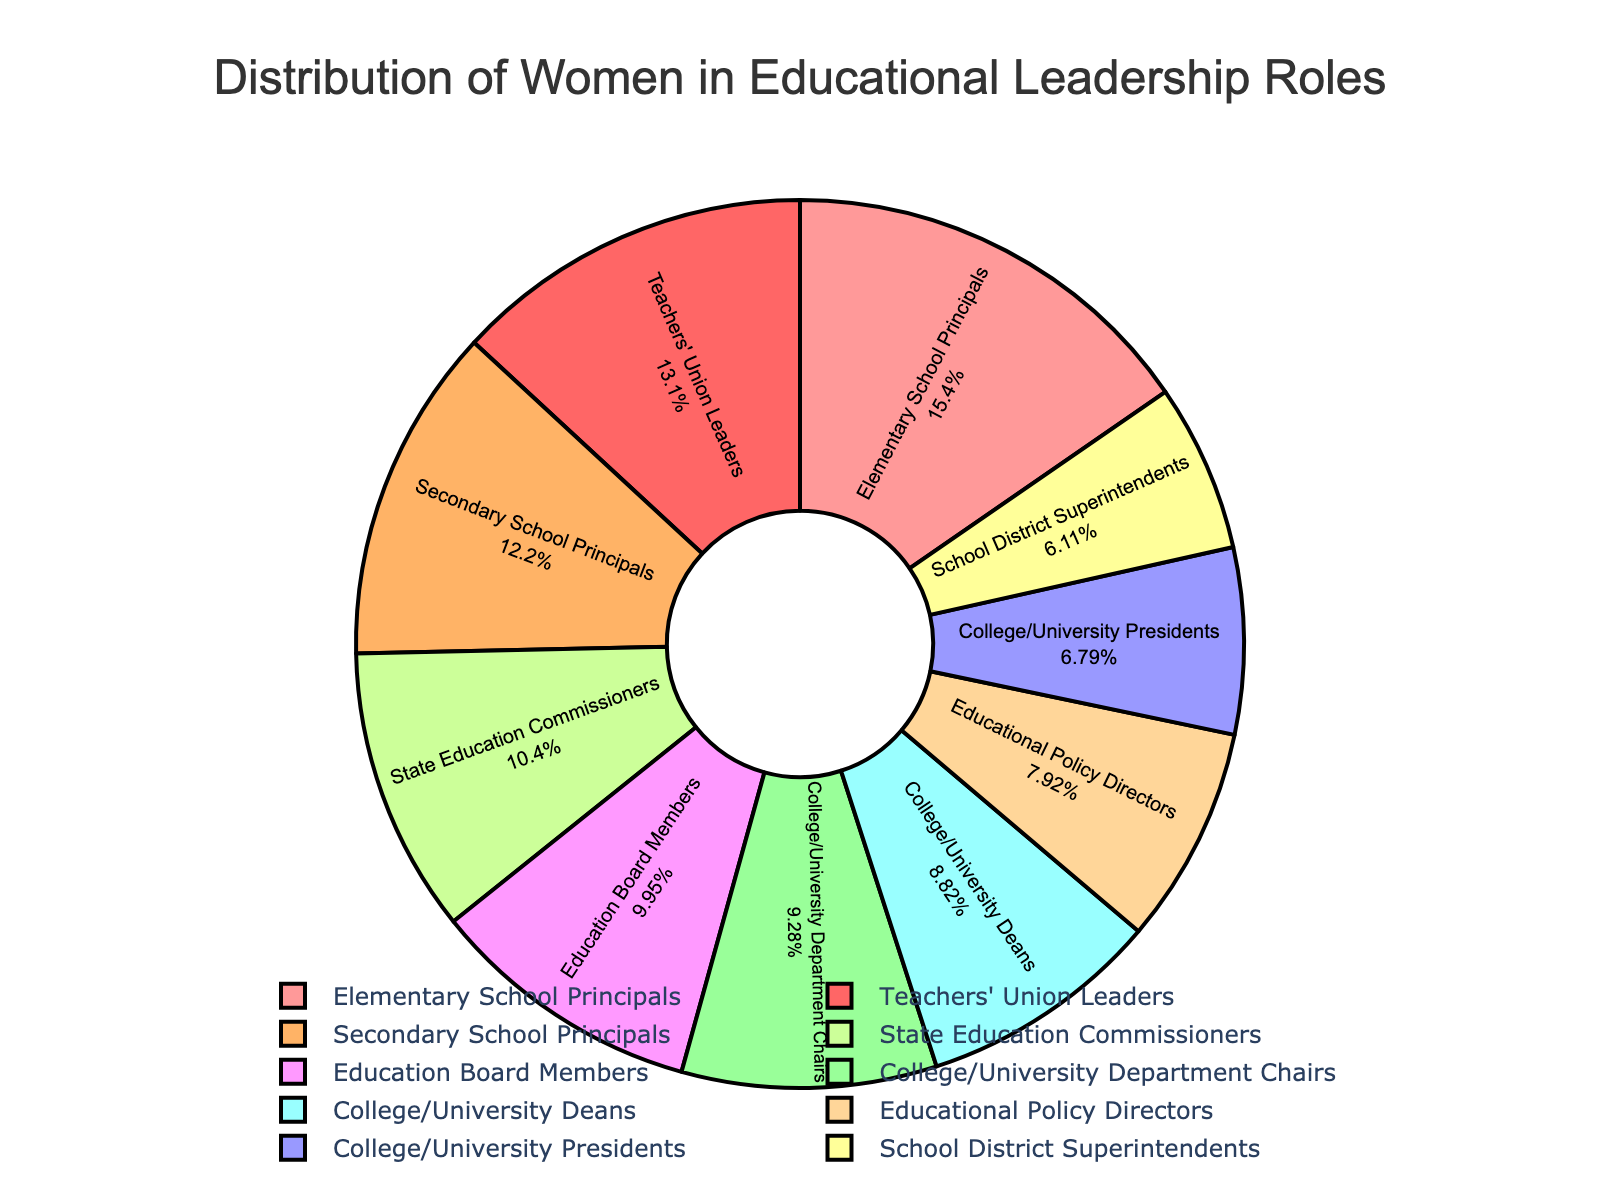Which educational level has the highest percentage of women in leadership roles? The pie chart segments represent different educational levels and their respective percentages of women in leadership roles. By observing the size of each segment, you can see that "Elementary School Principals" has the largest segment, indicating the highest percentage at 68%.
Answer: Elementary School Principals Which educational level has the lowest percentage of women in leadership roles? By examining the pie chart, the smallest segment represents "School District Superintendents," which has the lowest percentage of women in leadership roles at 27%.
Answer: School District Superintendents Is the percentage of women in leadership roles for Secondary School Principals greater than that for College/University Presidents? The chart shows that Secondary School Principals have a 54% share, while College/University Presidents have a 30% share. Thus, 54% is greater than 30%.
Answer: Yes What is the percentage difference between Educational Policy Directors and College/University Deans in leadership roles? Educational Policy Directors have 35%, and College/University Deans have 39%. The percentage difference is calculated as 39% - 35% = 4%.
Answer: 4% How does the percentage of women in State Education Commissioners compare to that of Education Board Members? State Education Commissioners have a 46% share, while Education Board Members have a 44% share. Therefore, State Education Commissioners have a 2% higher percentage.
Answer: State Education Commissioners have 2% more Which educational levels have more than 50% of women in leadership roles? Observing the pie chart, the levels with over 50% women are "Elementary School Principals" (68%), "Secondary School Principals" (54%), and "Teachers' Union Leaders" (58%).
Answer: Elementary School Principals, Secondary School Principals, Teachers' Union Leaders What is the average percentage of women in leadership roles for College/University-based positions? College/University-based positions are Department Chairs (41%), Deans (39%), and Presidents (30%). Average = (41 + 39 + 30) / 3 = 110 / 3 ≈ 36.67%.
Answer: Approximately 36.67% Are there more women in leadership roles as Educational Policy Directors or as State Education Commissioners? Comparing the two segments, Educational Policy Directors have 35%, and State Education Commissioners have 46%. Thus, there are more women in leadership roles as State Education Commissioners.
Answer: State Education Commissioners Which segment is represented by a green color in the pie chart? The segments are color-coded, and by looking at the green segment, it represents "School District Superintendents."
Answer: School District Superintendents What is the collective percentage of women in leadership roles for Secondary School Principals, State Education Commissioners, and Teachers' Union Leaders? Adding the percentages for these positions: Secondary School Principals (54%), State Education Commissioners (46%), and Teachers' Union Leaders (58%). The collective percentage is 54 + 46 + 58 = 158%.
Answer: 158% 